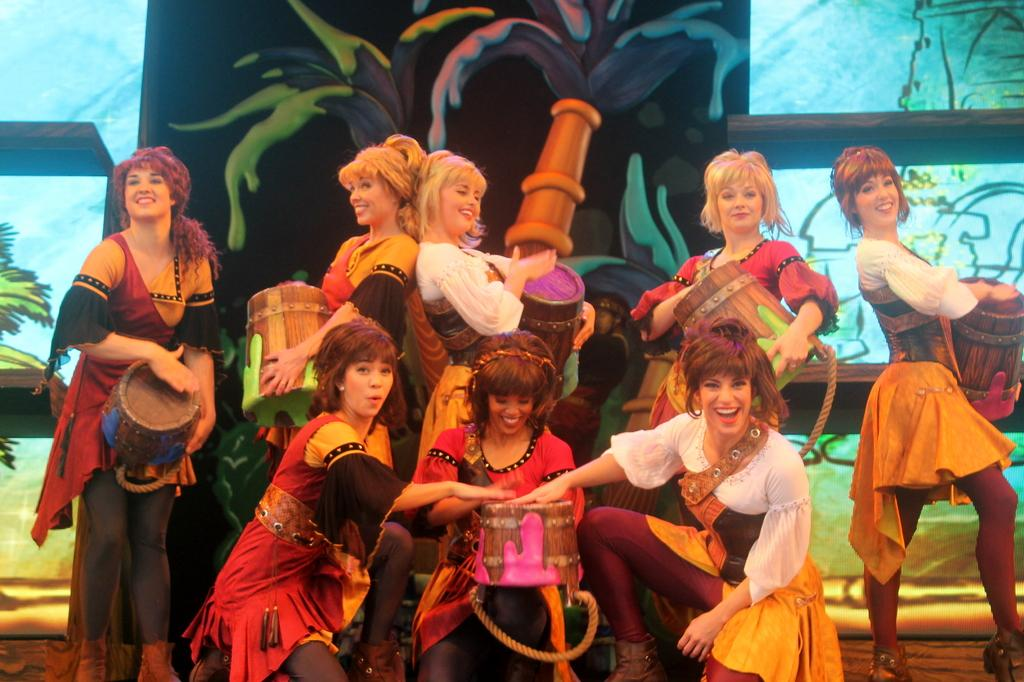What are the people in the image doing? The people in the image are playing musical instruments. Can you describe the background of the image? There is a painting in the background of the image. What type of box is being used as a source of authority in the image? There is no box or reference to authority present in the image; it features people playing musical instruments and a painting in the background. 